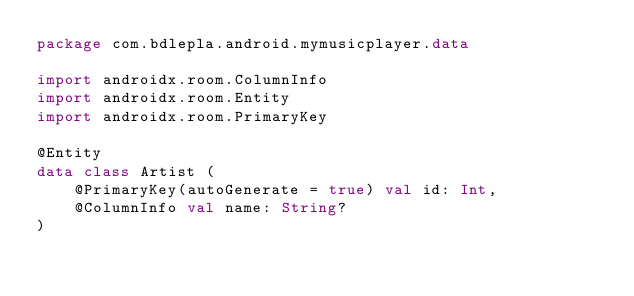<code> <loc_0><loc_0><loc_500><loc_500><_Kotlin_>package com.bdlepla.android.mymusicplayer.data

import androidx.room.ColumnInfo
import androidx.room.Entity
import androidx.room.PrimaryKey

@Entity
data class Artist (
    @PrimaryKey(autoGenerate = true) val id: Int,
    @ColumnInfo val name: String?
)</code> 